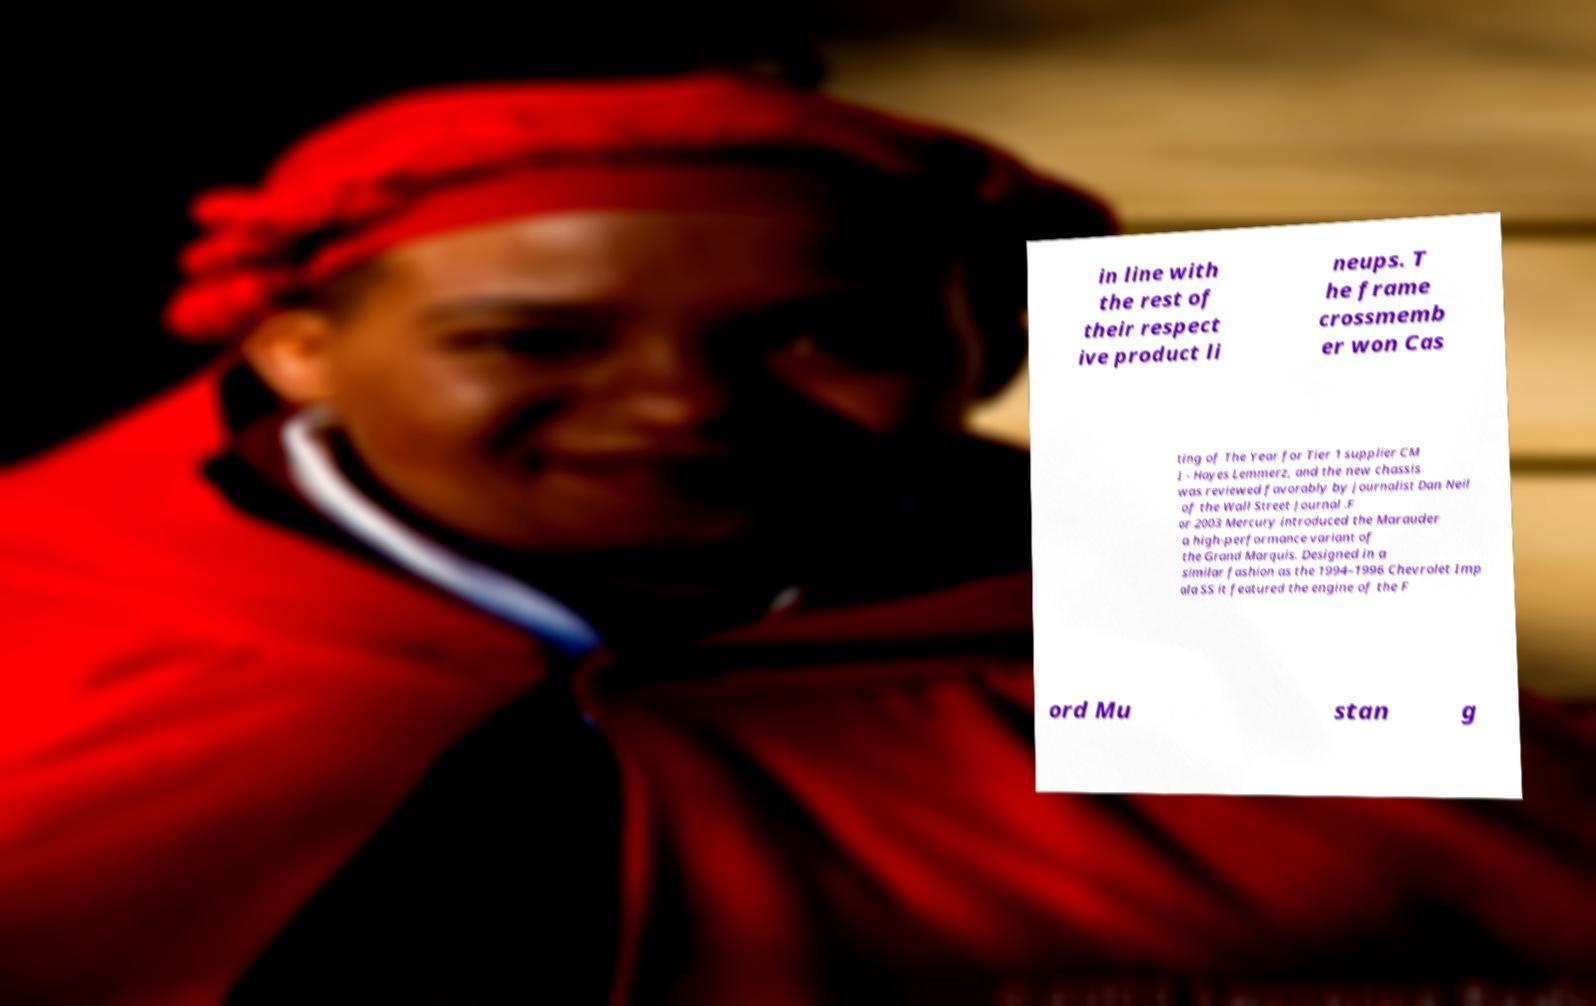Can you accurately transcribe the text from the provided image for me? in line with the rest of their respect ive product li neups. T he frame crossmemb er won Cas ting of The Year for Tier 1 supplier CM I - Hayes Lemmerz, and the new chassis was reviewed favorably by journalist Dan Neil of the Wall Street Journal .F or 2003 Mercury introduced the Marauder a high-performance variant of the Grand Marquis. Designed in a similar fashion as the 1994–1996 Chevrolet Imp ala SS it featured the engine of the F ord Mu stan g 